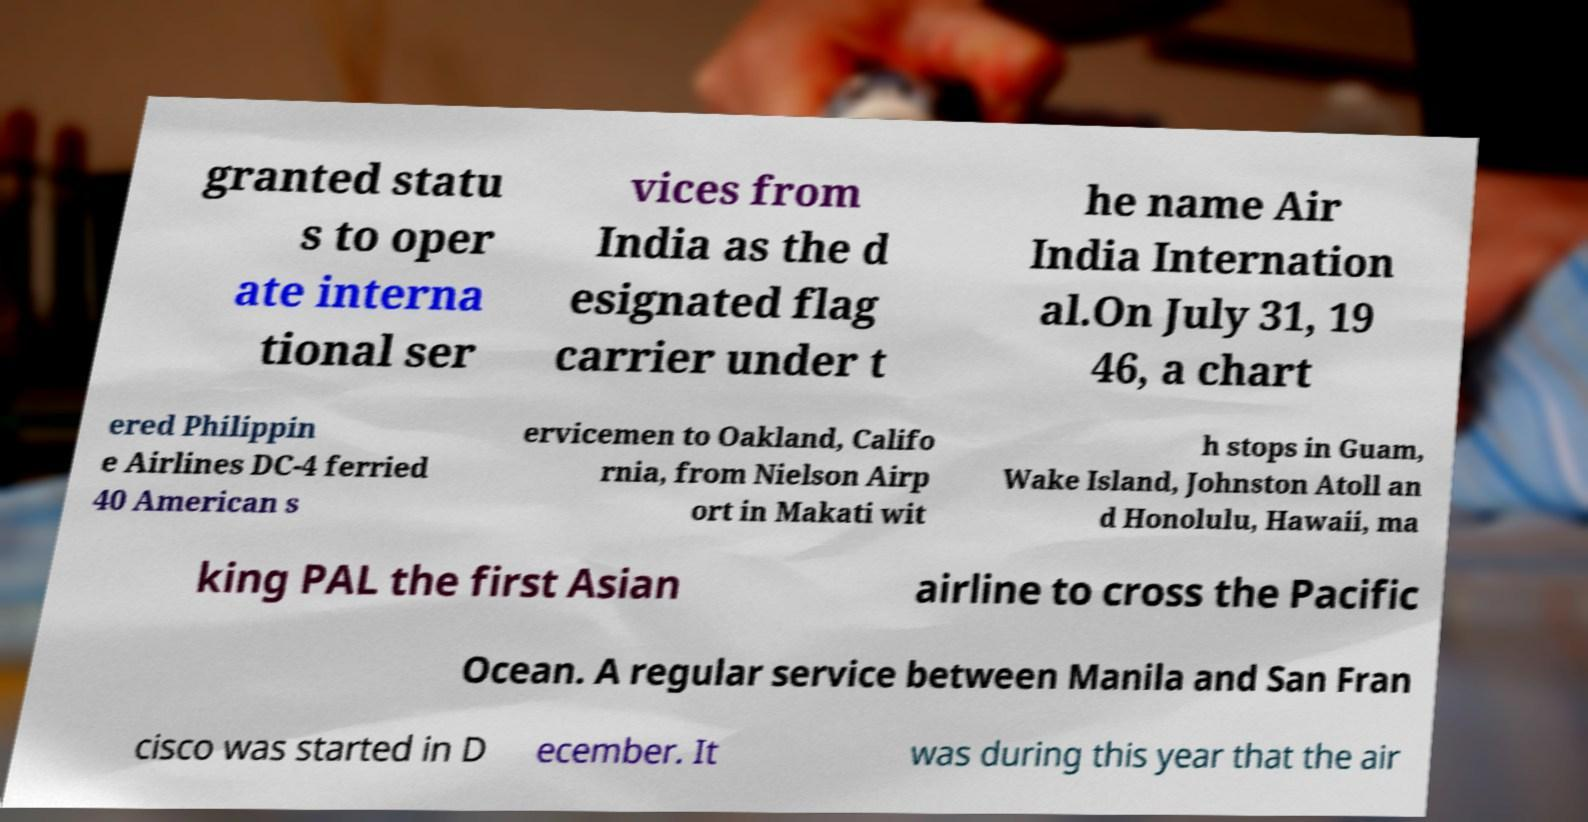Could you extract and type out the text from this image? granted statu s to oper ate interna tional ser vices from India as the d esignated flag carrier under t he name Air India Internation al.On July 31, 19 46, a chart ered Philippin e Airlines DC-4 ferried 40 American s ervicemen to Oakland, Califo rnia, from Nielson Airp ort in Makati wit h stops in Guam, Wake Island, Johnston Atoll an d Honolulu, Hawaii, ma king PAL the first Asian airline to cross the Pacific Ocean. A regular service between Manila and San Fran cisco was started in D ecember. It was during this year that the air 